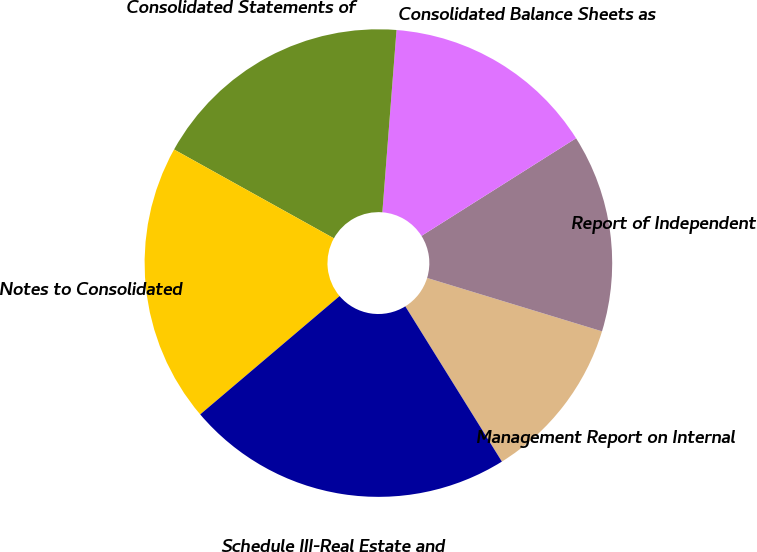<chart> <loc_0><loc_0><loc_500><loc_500><pie_chart><fcel>Management Report on Internal<fcel>Report of Independent<fcel>Consolidated Balance Sheets as<fcel>Consolidated Statements of<fcel>Notes to Consolidated<fcel>Schedule III-Real Estate and<nl><fcel>11.43%<fcel>13.68%<fcel>14.8%<fcel>18.16%<fcel>19.28%<fcel>22.65%<nl></chart> 